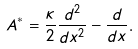Convert formula to latex. <formula><loc_0><loc_0><loc_500><loc_500>A ^ { * } = \frac { \kappa } { 2 } \frac { d ^ { 2 } } { d x ^ { 2 } } - \frac { d } { d x } .</formula> 